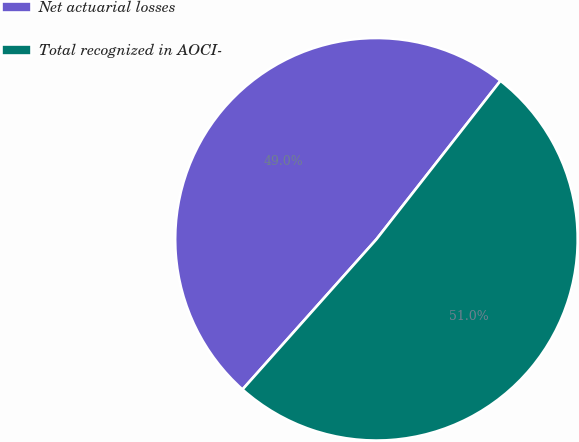Convert chart. <chart><loc_0><loc_0><loc_500><loc_500><pie_chart><fcel>Net actuarial losses<fcel>Total recognized in AOCI-<nl><fcel>48.98%<fcel>51.02%<nl></chart> 